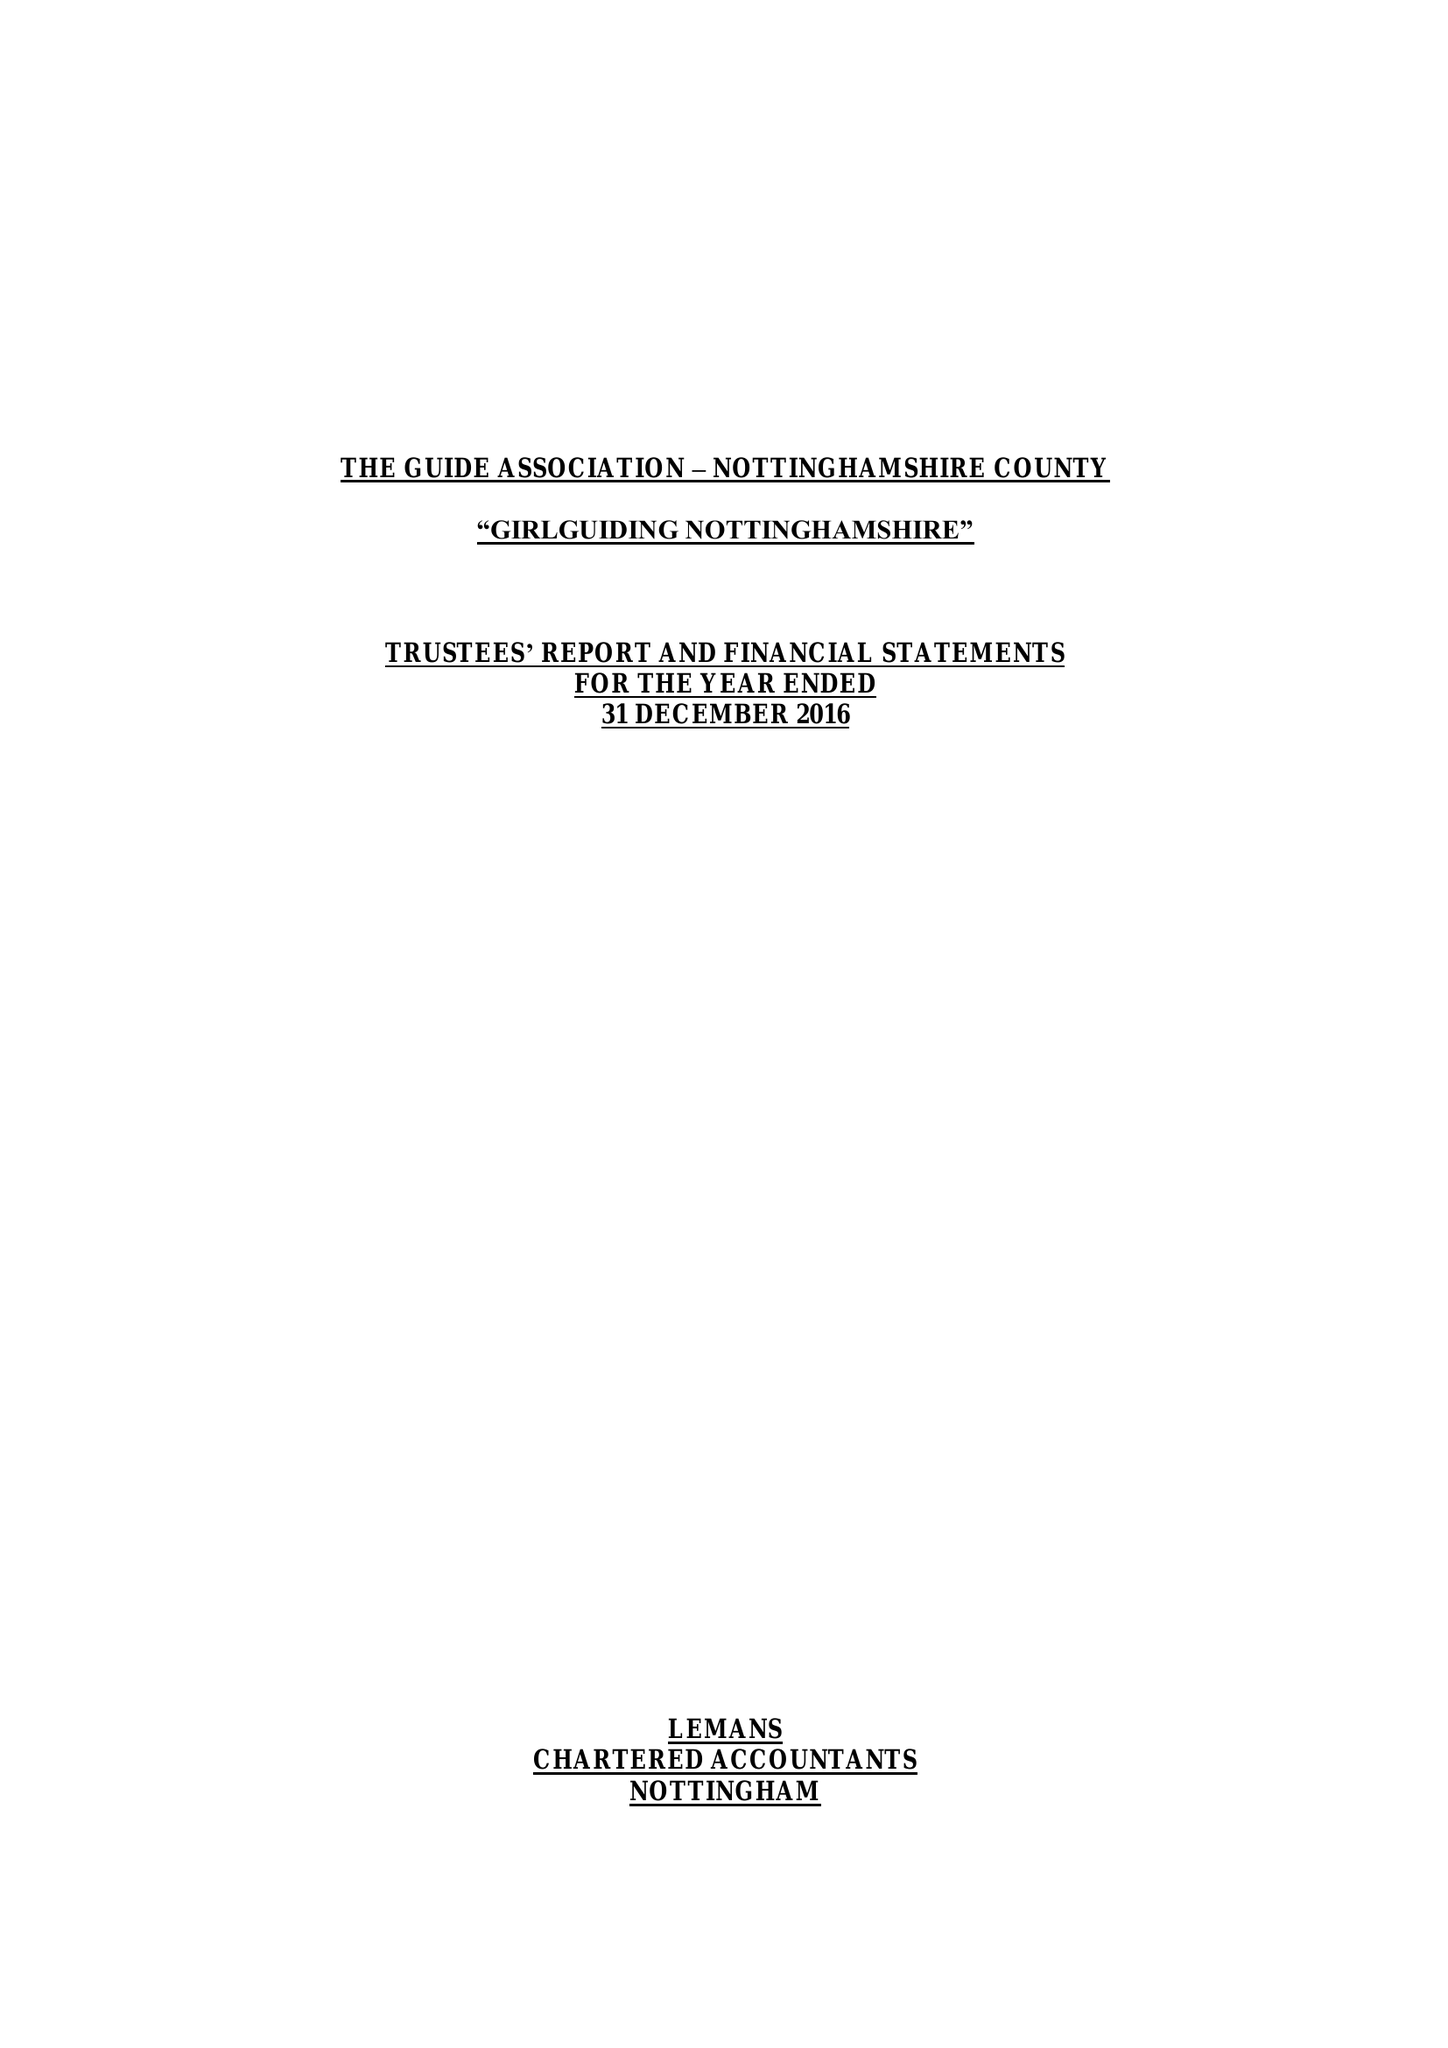What is the value for the report_date?
Answer the question using a single word or phrase. 2016-12-31 